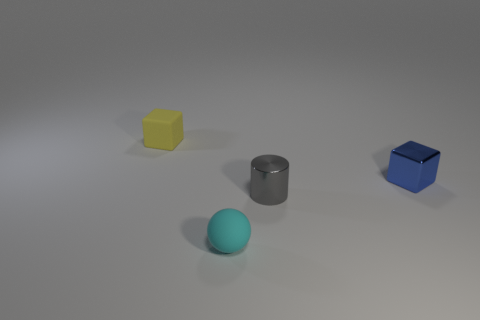Add 4 tiny shiny blocks. How many objects exist? 8 Subtract all yellow matte things. Subtract all cyan rubber balls. How many objects are left? 2 Add 3 gray things. How many gray things are left? 4 Add 1 small gray things. How many small gray things exist? 2 Subtract 0 green cylinders. How many objects are left? 4 